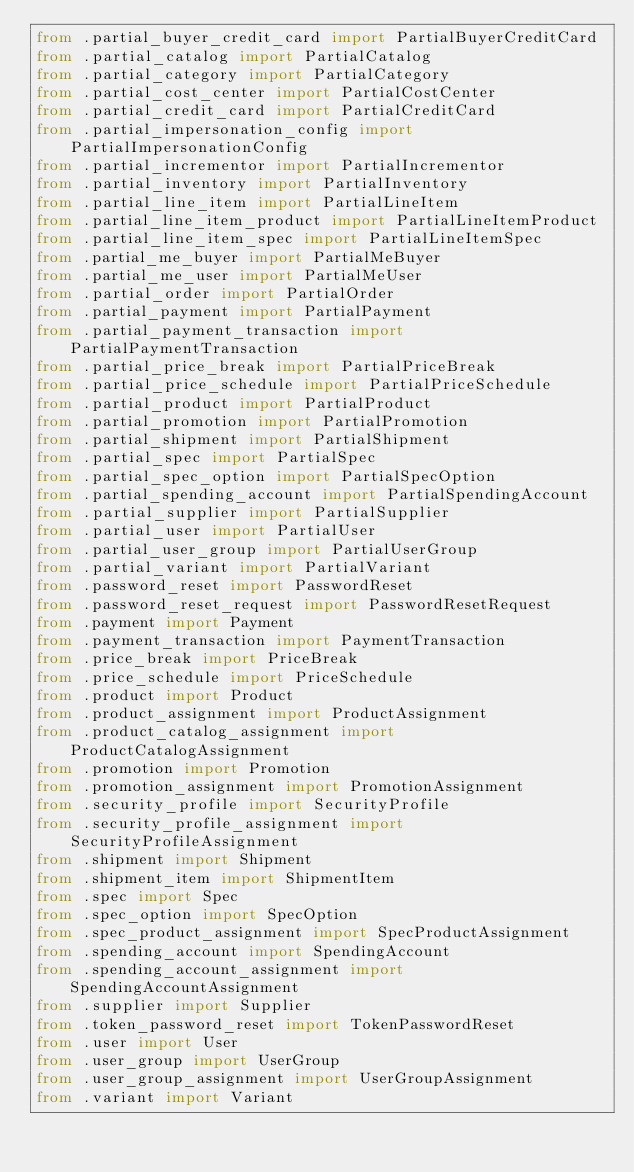<code> <loc_0><loc_0><loc_500><loc_500><_Python_>from .partial_buyer_credit_card import PartialBuyerCreditCard
from .partial_catalog import PartialCatalog
from .partial_category import PartialCategory
from .partial_cost_center import PartialCostCenter
from .partial_credit_card import PartialCreditCard
from .partial_impersonation_config import PartialImpersonationConfig
from .partial_incrementor import PartialIncrementor
from .partial_inventory import PartialInventory
from .partial_line_item import PartialLineItem
from .partial_line_item_product import PartialLineItemProduct
from .partial_line_item_spec import PartialLineItemSpec
from .partial_me_buyer import PartialMeBuyer
from .partial_me_user import PartialMeUser
from .partial_order import PartialOrder
from .partial_payment import PartialPayment
from .partial_payment_transaction import PartialPaymentTransaction
from .partial_price_break import PartialPriceBreak
from .partial_price_schedule import PartialPriceSchedule
from .partial_product import PartialProduct
from .partial_promotion import PartialPromotion
from .partial_shipment import PartialShipment
from .partial_spec import PartialSpec
from .partial_spec_option import PartialSpecOption
from .partial_spending_account import PartialSpendingAccount
from .partial_supplier import PartialSupplier
from .partial_user import PartialUser
from .partial_user_group import PartialUserGroup
from .partial_variant import PartialVariant
from .password_reset import PasswordReset
from .password_reset_request import PasswordResetRequest
from .payment import Payment
from .payment_transaction import PaymentTransaction
from .price_break import PriceBreak
from .price_schedule import PriceSchedule
from .product import Product
from .product_assignment import ProductAssignment
from .product_catalog_assignment import ProductCatalogAssignment
from .promotion import Promotion
from .promotion_assignment import PromotionAssignment
from .security_profile import SecurityProfile
from .security_profile_assignment import SecurityProfileAssignment
from .shipment import Shipment
from .shipment_item import ShipmentItem
from .spec import Spec
from .spec_option import SpecOption
from .spec_product_assignment import SpecProductAssignment
from .spending_account import SpendingAccount
from .spending_account_assignment import SpendingAccountAssignment
from .supplier import Supplier
from .token_password_reset import TokenPasswordReset
from .user import User
from .user_group import UserGroup
from .user_group_assignment import UserGroupAssignment
from .variant import Variant
</code> 